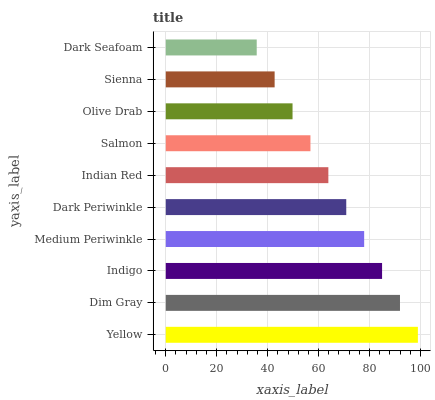Is Dark Seafoam the minimum?
Answer yes or no. Yes. Is Yellow the maximum?
Answer yes or no. Yes. Is Dim Gray the minimum?
Answer yes or no. No. Is Dim Gray the maximum?
Answer yes or no. No. Is Yellow greater than Dim Gray?
Answer yes or no. Yes. Is Dim Gray less than Yellow?
Answer yes or no. Yes. Is Dim Gray greater than Yellow?
Answer yes or no. No. Is Yellow less than Dim Gray?
Answer yes or no. No. Is Dark Periwinkle the high median?
Answer yes or no. Yes. Is Indian Red the low median?
Answer yes or no. Yes. Is Indian Red the high median?
Answer yes or no. No. Is Sienna the low median?
Answer yes or no. No. 